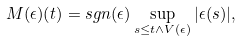Convert formula to latex. <formula><loc_0><loc_0><loc_500><loc_500>M ( \epsilon ) ( t ) = s g n ( \epsilon ) \sup _ { s \leq t \land V ( \epsilon ) } | \epsilon ( s ) | ,</formula> 